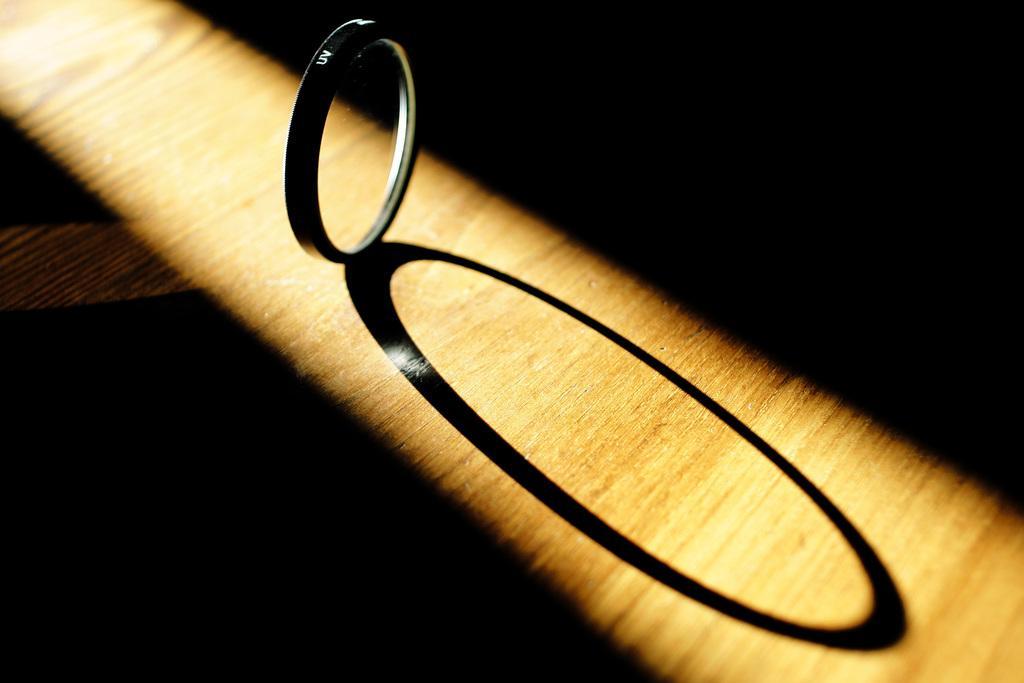How would you summarize this image in a sentence or two? This picture shows a ring on the table and we see a shadow of the ring. 